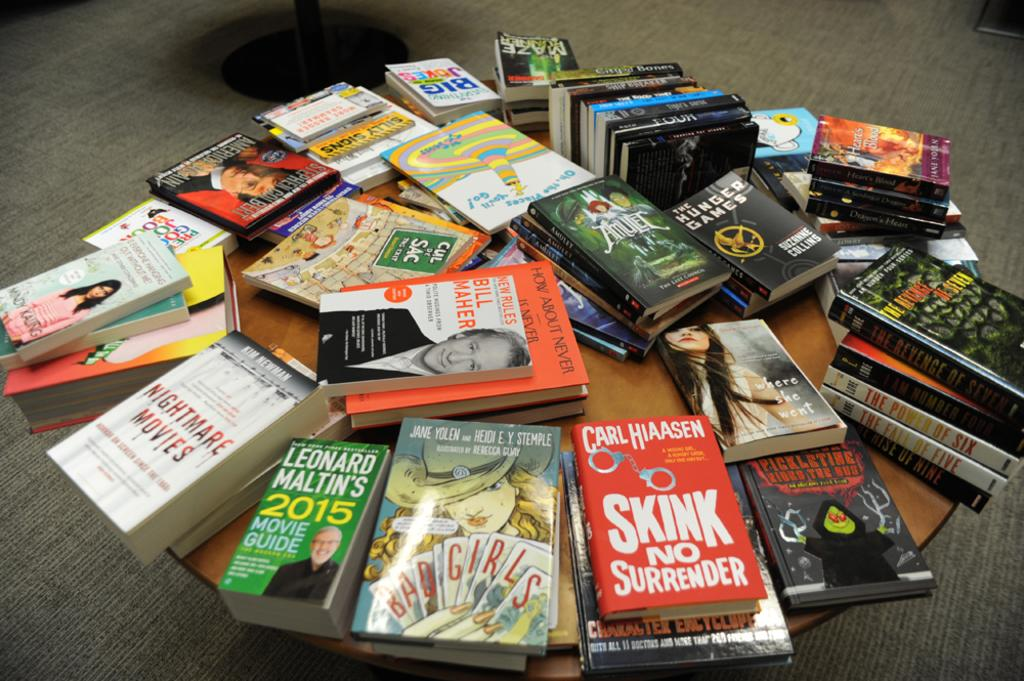Provide a one-sentence caption for the provided image. A large collection of books sit on a table, including one entitled Bad Girls. 